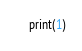Convert code to text. <code><loc_0><loc_0><loc_500><loc_500><_Python_>print(1)</code> 